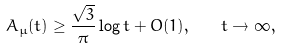Convert formula to latex. <formula><loc_0><loc_0><loc_500><loc_500>A _ { \mu } ( t ) \geq \frac { \sqrt { 3 } } { \pi } \log t + O ( 1 ) , \quad t \to \infty ,</formula> 